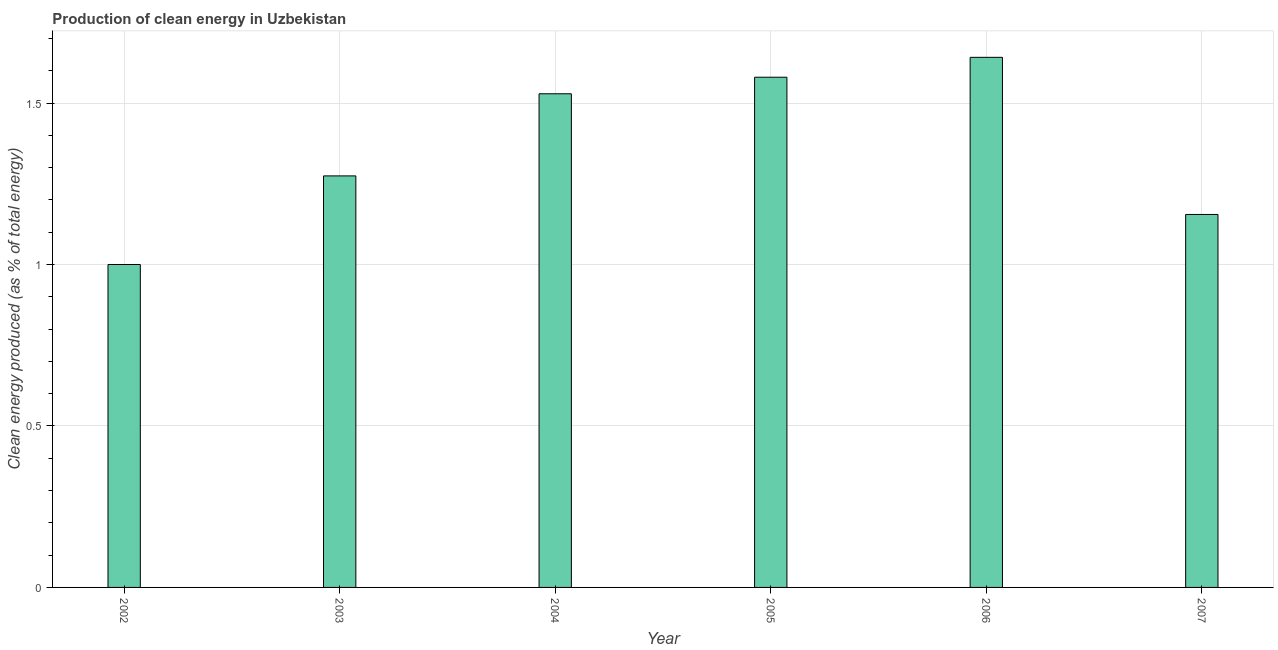Does the graph contain any zero values?
Offer a terse response. No. What is the title of the graph?
Ensure brevity in your answer.  Production of clean energy in Uzbekistan. What is the label or title of the X-axis?
Your answer should be very brief. Year. What is the label or title of the Y-axis?
Offer a very short reply. Clean energy produced (as % of total energy). What is the production of clean energy in 2004?
Make the answer very short. 1.53. Across all years, what is the maximum production of clean energy?
Provide a short and direct response. 1.64. Across all years, what is the minimum production of clean energy?
Offer a very short reply. 1. What is the sum of the production of clean energy?
Your answer should be compact. 8.18. What is the difference between the production of clean energy in 2004 and 2005?
Offer a terse response. -0.05. What is the average production of clean energy per year?
Provide a succinct answer. 1.36. What is the median production of clean energy?
Ensure brevity in your answer.  1.4. What is the ratio of the production of clean energy in 2003 to that in 2005?
Provide a succinct answer. 0.81. Is the production of clean energy in 2004 less than that in 2007?
Make the answer very short. No. Is the difference between the production of clean energy in 2002 and 2005 greater than the difference between any two years?
Offer a very short reply. No. What is the difference between the highest and the second highest production of clean energy?
Offer a terse response. 0.06. Is the sum of the production of clean energy in 2004 and 2005 greater than the maximum production of clean energy across all years?
Ensure brevity in your answer.  Yes. What is the difference between the highest and the lowest production of clean energy?
Ensure brevity in your answer.  0.64. In how many years, is the production of clean energy greater than the average production of clean energy taken over all years?
Ensure brevity in your answer.  3. How many years are there in the graph?
Your response must be concise. 6. What is the difference between two consecutive major ticks on the Y-axis?
Your answer should be compact. 0.5. What is the Clean energy produced (as % of total energy) in 2002?
Your answer should be compact. 1. What is the Clean energy produced (as % of total energy) in 2003?
Keep it short and to the point. 1.27. What is the Clean energy produced (as % of total energy) of 2004?
Your response must be concise. 1.53. What is the Clean energy produced (as % of total energy) of 2005?
Keep it short and to the point. 1.58. What is the Clean energy produced (as % of total energy) in 2006?
Your response must be concise. 1.64. What is the Clean energy produced (as % of total energy) of 2007?
Make the answer very short. 1.16. What is the difference between the Clean energy produced (as % of total energy) in 2002 and 2003?
Give a very brief answer. -0.27. What is the difference between the Clean energy produced (as % of total energy) in 2002 and 2004?
Offer a terse response. -0.53. What is the difference between the Clean energy produced (as % of total energy) in 2002 and 2005?
Your response must be concise. -0.58. What is the difference between the Clean energy produced (as % of total energy) in 2002 and 2006?
Make the answer very short. -0.64. What is the difference between the Clean energy produced (as % of total energy) in 2002 and 2007?
Ensure brevity in your answer.  -0.15. What is the difference between the Clean energy produced (as % of total energy) in 2003 and 2004?
Keep it short and to the point. -0.25. What is the difference between the Clean energy produced (as % of total energy) in 2003 and 2005?
Offer a very short reply. -0.31. What is the difference between the Clean energy produced (as % of total energy) in 2003 and 2006?
Your response must be concise. -0.37. What is the difference between the Clean energy produced (as % of total energy) in 2003 and 2007?
Your answer should be compact. 0.12. What is the difference between the Clean energy produced (as % of total energy) in 2004 and 2005?
Give a very brief answer. -0.05. What is the difference between the Clean energy produced (as % of total energy) in 2004 and 2006?
Provide a succinct answer. -0.11. What is the difference between the Clean energy produced (as % of total energy) in 2004 and 2007?
Your answer should be compact. 0.37. What is the difference between the Clean energy produced (as % of total energy) in 2005 and 2006?
Ensure brevity in your answer.  -0.06. What is the difference between the Clean energy produced (as % of total energy) in 2005 and 2007?
Ensure brevity in your answer.  0.43. What is the difference between the Clean energy produced (as % of total energy) in 2006 and 2007?
Provide a succinct answer. 0.49. What is the ratio of the Clean energy produced (as % of total energy) in 2002 to that in 2003?
Your answer should be very brief. 0.79. What is the ratio of the Clean energy produced (as % of total energy) in 2002 to that in 2004?
Ensure brevity in your answer.  0.65. What is the ratio of the Clean energy produced (as % of total energy) in 2002 to that in 2005?
Give a very brief answer. 0.63. What is the ratio of the Clean energy produced (as % of total energy) in 2002 to that in 2006?
Your response must be concise. 0.61. What is the ratio of the Clean energy produced (as % of total energy) in 2002 to that in 2007?
Give a very brief answer. 0.87. What is the ratio of the Clean energy produced (as % of total energy) in 2003 to that in 2004?
Offer a very short reply. 0.83. What is the ratio of the Clean energy produced (as % of total energy) in 2003 to that in 2005?
Give a very brief answer. 0.81. What is the ratio of the Clean energy produced (as % of total energy) in 2003 to that in 2006?
Make the answer very short. 0.78. What is the ratio of the Clean energy produced (as % of total energy) in 2003 to that in 2007?
Offer a very short reply. 1.1. What is the ratio of the Clean energy produced (as % of total energy) in 2004 to that in 2005?
Keep it short and to the point. 0.97. What is the ratio of the Clean energy produced (as % of total energy) in 2004 to that in 2007?
Your answer should be very brief. 1.32. What is the ratio of the Clean energy produced (as % of total energy) in 2005 to that in 2006?
Keep it short and to the point. 0.96. What is the ratio of the Clean energy produced (as % of total energy) in 2005 to that in 2007?
Offer a terse response. 1.37. What is the ratio of the Clean energy produced (as % of total energy) in 2006 to that in 2007?
Ensure brevity in your answer.  1.42. 